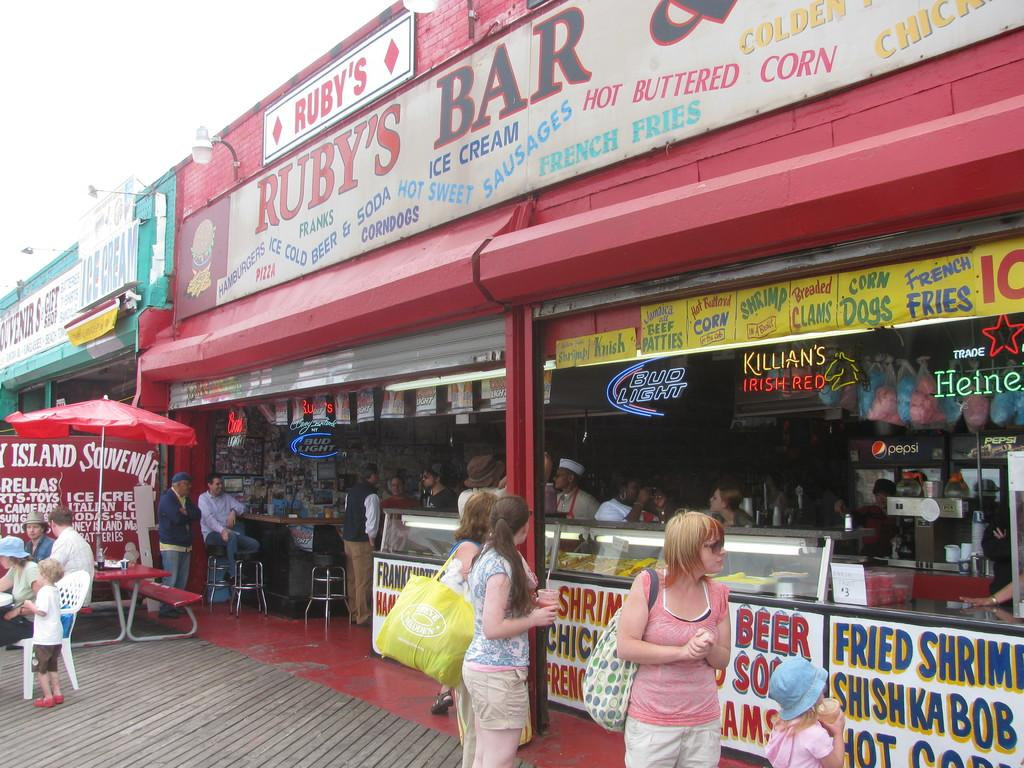Provide a one-sentence caption for the provided image. A group of people are walking by a restaurant on a boardwalk called Ruby's Bar. 